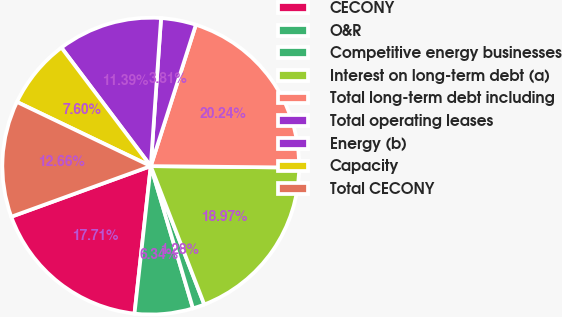Convert chart to OTSL. <chart><loc_0><loc_0><loc_500><loc_500><pie_chart><fcel>CECONY<fcel>O&R<fcel>Competitive energy businesses<fcel>Interest on long-term debt (a)<fcel>Total long-term debt including<fcel>Total operating leases<fcel>Energy (b)<fcel>Capacity<fcel>Total CECONY<nl><fcel>17.71%<fcel>6.34%<fcel>1.28%<fcel>18.97%<fcel>20.24%<fcel>3.81%<fcel>11.39%<fcel>7.6%<fcel>12.66%<nl></chart> 